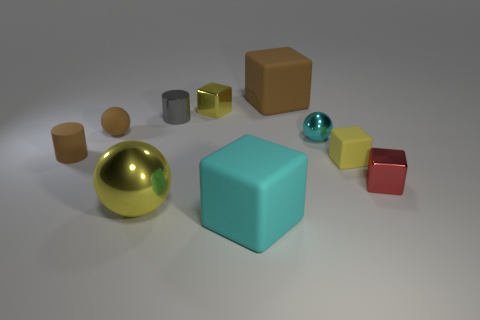Are there any other things of the same color as the small shiny cylinder?
Provide a short and direct response. No. What number of rubber objects are either big yellow things or big gray things?
Your answer should be very brief. 0. There is a tiny yellow rubber cube that is on the right side of the yellow shiny object behind the large shiny ball; is there a matte block behind it?
Ensure brevity in your answer.  Yes. How many brown objects are to the right of the small rubber cylinder?
Keep it short and to the point. 2. What material is the other small block that is the same color as the small rubber block?
Your answer should be very brief. Metal. How many tiny objects are things or rubber blocks?
Ensure brevity in your answer.  7. What shape is the matte object that is behind the tiny metallic cylinder?
Make the answer very short. Cube. Is there a cube that has the same color as the tiny matte sphere?
Keep it short and to the point. Yes. Is the size of the rubber cube on the right side of the small cyan metallic object the same as the metal ball in front of the small red shiny cube?
Make the answer very short. No. Is the number of tiny blocks right of the tiny cyan thing greater than the number of small brown cylinders that are to the left of the brown matte cylinder?
Provide a succinct answer. Yes. 